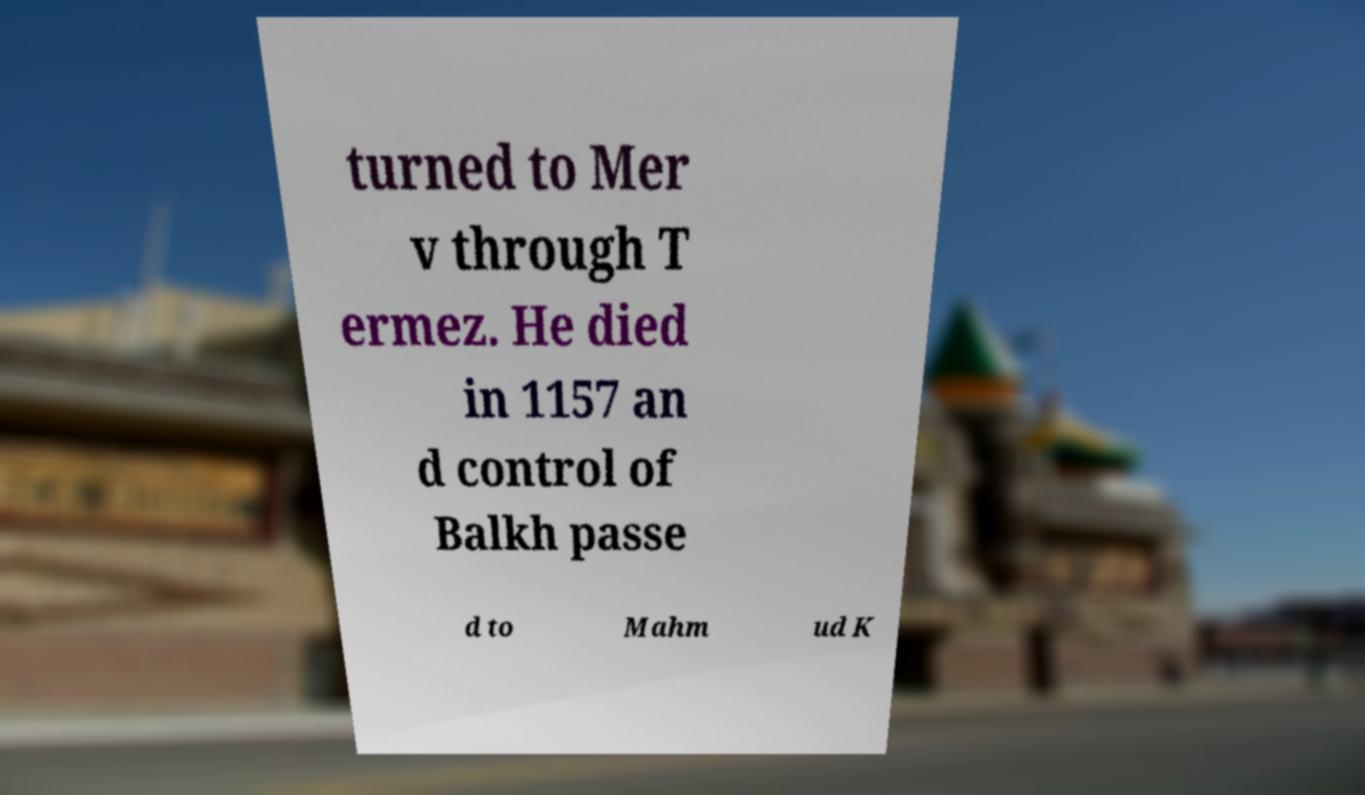Please identify and transcribe the text found in this image. turned to Mer v through T ermez. He died in 1157 an d control of Balkh passe d to Mahm ud K 